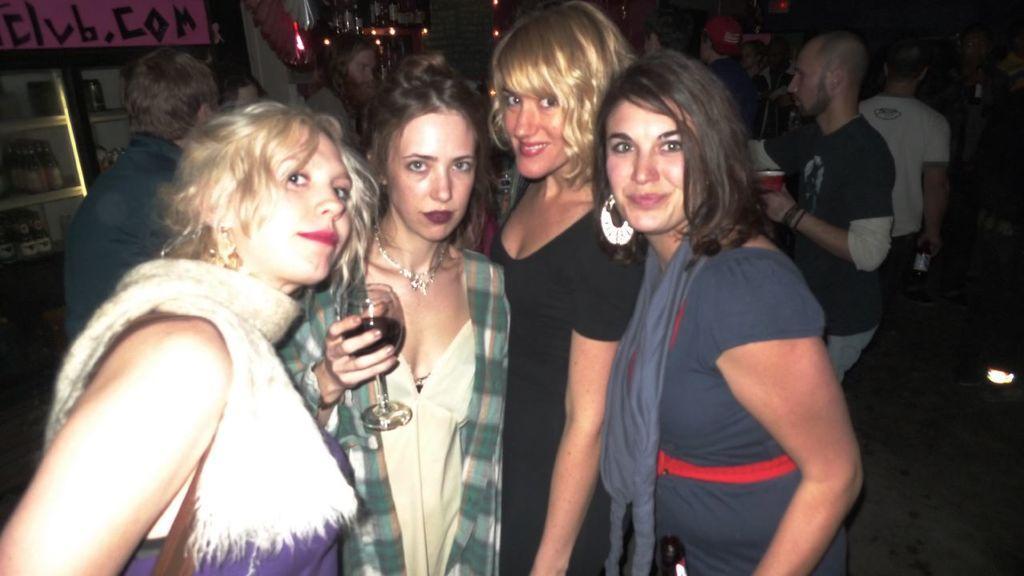Describe this image in one or two sentences. In this picture we can see some people standing, a woman in the middle is holding a glass of drink, on the left side there is a refrigerator, we can see some bottles in the refrigerator, we can see some lights in the background. 